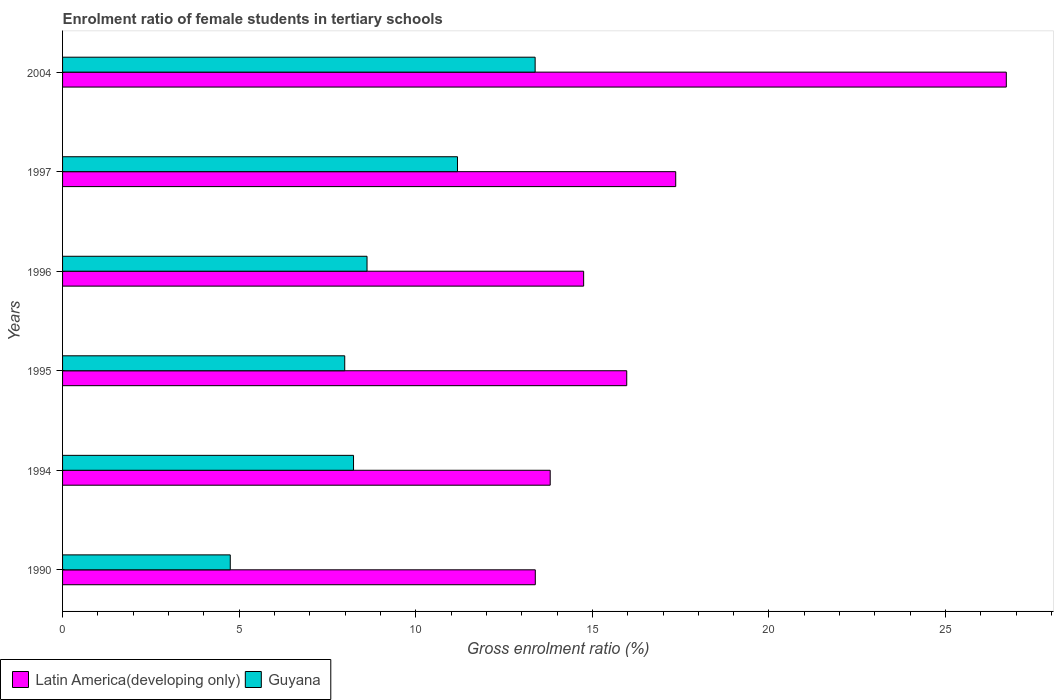How many different coloured bars are there?
Provide a short and direct response. 2. How many bars are there on the 3rd tick from the top?
Give a very brief answer. 2. What is the label of the 6th group of bars from the top?
Your answer should be compact. 1990. In how many cases, is the number of bars for a given year not equal to the number of legend labels?
Your answer should be compact. 0. What is the enrolment ratio of female students in tertiary schools in Latin America(developing only) in 1995?
Ensure brevity in your answer.  15.97. Across all years, what is the maximum enrolment ratio of female students in tertiary schools in Guyana?
Provide a succinct answer. 13.38. Across all years, what is the minimum enrolment ratio of female students in tertiary schools in Latin America(developing only)?
Your response must be concise. 13.38. In which year was the enrolment ratio of female students in tertiary schools in Guyana minimum?
Ensure brevity in your answer.  1990. What is the total enrolment ratio of female students in tertiary schools in Latin America(developing only) in the graph?
Offer a terse response. 101.99. What is the difference between the enrolment ratio of female students in tertiary schools in Latin America(developing only) in 1990 and that in 1994?
Offer a terse response. -0.42. What is the difference between the enrolment ratio of female students in tertiary schools in Latin America(developing only) in 1994 and the enrolment ratio of female students in tertiary schools in Guyana in 1995?
Offer a very short reply. 5.82. What is the average enrolment ratio of female students in tertiary schools in Latin America(developing only) per year?
Keep it short and to the point. 17. In the year 1996, what is the difference between the enrolment ratio of female students in tertiary schools in Guyana and enrolment ratio of female students in tertiary schools in Latin America(developing only)?
Your answer should be very brief. -6.13. In how many years, is the enrolment ratio of female students in tertiary schools in Latin America(developing only) greater than 7 %?
Your response must be concise. 6. What is the ratio of the enrolment ratio of female students in tertiary schools in Latin America(developing only) in 1990 to that in 2004?
Keep it short and to the point. 0.5. What is the difference between the highest and the second highest enrolment ratio of female students in tertiary schools in Latin America(developing only)?
Offer a very short reply. 9.36. What is the difference between the highest and the lowest enrolment ratio of female students in tertiary schools in Guyana?
Offer a terse response. 8.63. In how many years, is the enrolment ratio of female students in tertiary schools in Latin America(developing only) greater than the average enrolment ratio of female students in tertiary schools in Latin America(developing only) taken over all years?
Ensure brevity in your answer.  2. What does the 2nd bar from the top in 2004 represents?
Give a very brief answer. Latin America(developing only). What does the 2nd bar from the bottom in 1990 represents?
Ensure brevity in your answer.  Guyana. How many bars are there?
Offer a very short reply. 12. Are all the bars in the graph horizontal?
Keep it short and to the point. Yes. How many years are there in the graph?
Offer a terse response. 6. What is the difference between two consecutive major ticks on the X-axis?
Make the answer very short. 5. Does the graph contain any zero values?
Your response must be concise. No. How are the legend labels stacked?
Offer a very short reply. Horizontal. What is the title of the graph?
Provide a succinct answer. Enrolment ratio of female students in tertiary schools. What is the Gross enrolment ratio (%) in Latin America(developing only) in 1990?
Your answer should be compact. 13.38. What is the Gross enrolment ratio (%) in Guyana in 1990?
Make the answer very short. 4.75. What is the Gross enrolment ratio (%) in Latin America(developing only) in 1994?
Offer a very short reply. 13.81. What is the Gross enrolment ratio (%) of Guyana in 1994?
Offer a very short reply. 8.24. What is the Gross enrolment ratio (%) of Latin America(developing only) in 1995?
Offer a terse response. 15.97. What is the Gross enrolment ratio (%) of Guyana in 1995?
Provide a short and direct response. 7.99. What is the Gross enrolment ratio (%) of Latin America(developing only) in 1996?
Your answer should be very brief. 14.75. What is the Gross enrolment ratio (%) in Guyana in 1996?
Provide a succinct answer. 8.62. What is the Gross enrolment ratio (%) in Latin America(developing only) in 1997?
Offer a very short reply. 17.36. What is the Gross enrolment ratio (%) in Guyana in 1997?
Provide a short and direct response. 11.18. What is the Gross enrolment ratio (%) of Latin America(developing only) in 2004?
Your response must be concise. 26.72. What is the Gross enrolment ratio (%) in Guyana in 2004?
Your response must be concise. 13.38. Across all years, what is the maximum Gross enrolment ratio (%) of Latin America(developing only)?
Ensure brevity in your answer.  26.72. Across all years, what is the maximum Gross enrolment ratio (%) in Guyana?
Your answer should be compact. 13.38. Across all years, what is the minimum Gross enrolment ratio (%) in Latin America(developing only)?
Make the answer very short. 13.38. Across all years, what is the minimum Gross enrolment ratio (%) of Guyana?
Keep it short and to the point. 4.75. What is the total Gross enrolment ratio (%) of Latin America(developing only) in the graph?
Provide a short and direct response. 101.99. What is the total Gross enrolment ratio (%) of Guyana in the graph?
Your answer should be very brief. 54.15. What is the difference between the Gross enrolment ratio (%) of Latin America(developing only) in 1990 and that in 1994?
Provide a short and direct response. -0.42. What is the difference between the Gross enrolment ratio (%) of Guyana in 1990 and that in 1994?
Your response must be concise. -3.49. What is the difference between the Gross enrolment ratio (%) of Latin America(developing only) in 1990 and that in 1995?
Provide a succinct answer. -2.59. What is the difference between the Gross enrolment ratio (%) of Guyana in 1990 and that in 1995?
Offer a very short reply. -3.24. What is the difference between the Gross enrolment ratio (%) in Latin America(developing only) in 1990 and that in 1996?
Make the answer very short. -1.37. What is the difference between the Gross enrolment ratio (%) of Guyana in 1990 and that in 1996?
Offer a very short reply. -3.87. What is the difference between the Gross enrolment ratio (%) of Latin America(developing only) in 1990 and that in 1997?
Your response must be concise. -3.98. What is the difference between the Gross enrolment ratio (%) in Guyana in 1990 and that in 1997?
Provide a succinct answer. -6.43. What is the difference between the Gross enrolment ratio (%) of Latin America(developing only) in 1990 and that in 2004?
Provide a succinct answer. -13.34. What is the difference between the Gross enrolment ratio (%) of Guyana in 1990 and that in 2004?
Ensure brevity in your answer.  -8.63. What is the difference between the Gross enrolment ratio (%) of Latin America(developing only) in 1994 and that in 1995?
Offer a very short reply. -2.17. What is the difference between the Gross enrolment ratio (%) in Guyana in 1994 and that in 1995?
Provide a short and direct response. 0.25. What is the difference between the Gross enrolment ratio (%) in Latin America(developing only) in 1994 and that in 1996?
Provide a succinct answer. -0.95. What is the difference between the Gross enrolment ratio (%) of Guyana in 1994 and that in 1996?
Offer a very short reply. -0.38. What is the difference between the Gross enrolment ratio (%) in Latin America(developing only) in 1994 and that in 1997?
Your response must be concise. -3.55. What is the difference between the Gross enrolment ratio (%) in Guyana in 1994 and that in 1997?
Provide a succinct answer. -2.94. What is the difference between the Gross enrolment ratio (%) in Latin America(developing only) in 1994 and that in 2004?
Your response must be concise. -12.91. What is the difference between the Gross enrolment ratio (%) in Guyana in 1994 and that in 2004?
Offer a very short reply. -5.14. What is the difference between the Gross enrolment ratio (%) of Latin America(developing only) in 1995 and that in 1996?
Provide a short and direct response. 1.22. What is the difference between the Gross enrolment ratio (%) in Guyana in 1995 and that in 1996?
Give a very brief answer. -0.63. What is the difference between the Gross enrolment ratio (%) of Latin America(developing only) in 1995 and that in 1997?
Give a very brief answer. -1.39. What is the difference between the Gross enrolment ratio (%) in Guyana in 1995 and that in 1997?
Give a very brief answer. -3.19. What is the difference between the Gross enrolment ratio (%) of Latin America(developing only) in 1995 and that in 2004?
Ensure brevity in your answer.  -10.75. What is the difference between the Gross enrolment ratio (%) of Guyana in 1995 and that in 2004?
Give a very brief answer. -5.39. What is the difference between the Gross enrolment ratio (%) in Latin America(developing only) in 1996 and that in 1997?
Your answer should be very brief. -2.61. What is the difference between the Gross enrolment ratio (%) of Guyana in 1996 and that in 1997?
Make the answer very short. -2.56. What is the difference between the Gross enrolment ratio (%) in Latin America(developing only) in 1996 and that in 2004?
Give a very brief answer. -11.97. What is the difference between the Gross enrolment ratio (%) of Guyana in 1996 and that in 2004?
Offer a terse response. -4.76. What is the difference between the Gross enrolment ratio (%) of Latin America(developing only) in 1997 and that in 2004?
Your answer should be compact. -9.36. What is the difference between the Gross enrolment ratio (%) in Guyana in 1997 and that in 2004?
Give a very brief answer. -2.2. What is the difference between the Gross enrolment ratio (%) in Latin America(developing only) in 1990 and the Gross enrolment ratio (%) in Guyana in 1994?
Make the answer very short. 5.15. What is the difference between the Gross enrolment ratio (%) in Latin America(developing only) in 1990 and the Gross enrolment ratio (%) in Guyana in 1995?
Offer a very short reply. 5.4. What is the difference between the Gross enrolment ratio (%) in Latin America(developing only) in 1990 and the Gross enrolment ratio (%) in Guyana in 1996?
Provide a succinct answer. 4.76. What is the difference between the Gross enrolment ratio (%) in Latin America(developing only) in 1990 and the Gross enrolment ratio (%) in Guyana in 1997?
Your answer should be very brief. 2.2. What is the difference between the Gross enrolment ratio (%) in Latin America(developing only) in 1990 and the Gross enrolment ratio (%) in Guyana in 2004?
Ensure brevity in your answer.  0. What is the difference between the Gross enrolment ratio (%) in Latin America(developing only) in 1994 and the Gross enrolment ratio (%) in Guyana in 1995?
Give a very brief answer. 5.82. What is the difference between the Gross enrolment ratio (%) of Latin America(developing only) in 1994 and the Gross enrolment ratio (%) of Guyana in 1996?
Give a very brief answer. 5.19. What is the difference between the Gross enrolment ratio (%) of Latin America(developing only) in 1994 and the Gross enrolment ratio (%) of Guyana in 1997?
Give a very brief answer. 2.62. What is the difference between the Gross enrolment ratio (%) of Latin America(developing only) in 1994 and the Gross enrolment ratio (%) of Guyana in 2004?
Your answer should be very brief. 0.43. What is the difference between the Gross enrolment ratio (%) of Latin America(developing only) in 1995 and the Gross enrolment ratio (%) of Guyana in 1996?
Keep it short and to the point. 7.35. What is the difference between the Gross enrolment ratio (%) in Latin America(developing only) in 1995 and the Gross enrolment ratio (%) in Guyana in 1997?
Your response must be concise. 4.79. What is the difference between the Gross enrolment ratio (%) in Latin America(developing only) in 1995 and the Gross enrolment ratio (%) in Guyana in 2004?
Offer a terse response. 2.59. What is the difference between the Gross enrolment ratio (%) of Latin America(developing only) in 1996 and the Gross enrolment ratio (%) of Guyana in 1997?
Offer a terse response. 3.57. What is the difference between the Gross enrolment ratio (%) of Latin America(developing only) in 1996 and the Gross enrolment ratio (%) of Guyana in 2004?
Your answer should be very brief. 1.37. What is the difference between the Gross enrolment ratio (%) of Latin America(developing only) in 1997 and the Gross enrolment ratio (%) of Guyana in 2004?
Offer a very short reply. 3.98. What is the average Gross enrolment ratio (%) in Latin America(developing only) per year?
Keep it short and to the point. 17. What is the average Gross enrolment ratio (%) of Guyana per year?
Provide a short and direct response. 9.03. In the year 1990, what is the difference between the Gross enrolment ratio (%) in Latin America(developing only) and Gross enrolment ratio (%) in Guyana?
Ensure brevity in your answer.  8.64. In the year 1994, what is the difference between the Gross enrolment ratio (%) in Latin America(developing only) and Gross enrolment ratio (%) in Guyana?
Make the answer very short. 5.57. In the year 1995, what is the difference between the Gross enrolment ratio (%) of Latin America(developing only) and Gross enrolment ratio (%) of Guyana?
Your response must be concise. 7.98. In the year 1996, what is the difference between the Gross enrolment ratio (%) of Latin America(developing only) and Gross enrolment ratio (%) of Guyana?
Your answer should be very brief. 6.13. In the year 1997, what is the difference between the Gross enrolment ratio (%) of Latin America(developing only) and Gross enrolment ratio (%) of Guyana?
Provide a succinct answer. 6.18. In the year 2004, what is the difference between the Gross enrolment ratio (%) of Latin America(developing only) and Gross enrolment ratio (%) of Guyana?
Give a very brief answer. 13.34. What is the ratio of the Gross enrolment ratio (%) of Latin America(developing only) in 1990 to that in 1994?
Your answer should be very brief. 0.97. What is the ratio of the Gross enrolment ratio (%) of Guyana in 1990 to that in 1994?
Your answer should be compact. 0.58. What is the ratio of the Gross enrolment ratio (%) in Latin America(developing only) in 1990 to that in 1995?
Offer a very short reply. 0.84. What is the ratio of the Gross enrolment ratio (%) of Guyana in 1990 to that in 1995?
Make the answer very short. 0.59. What is the ratio of the Gross enrolment ratio (%) in Latin America(developing only) in 1990 to that in 1996?
Make the answer very short. 0.91. What is the ratio of the Gross enrolment ratio (%) of Guyana in 1990 to that in 1996?
Offer a very short reply. 0.55. What is the ratio of the Gross enrolment ratio (%) of Latin America(developing only) in 1990 to that in 1997?
Ensure brevity in your answer.  0.77. What is the ratio of the Gross enrolment ratio (%) of Guyana in 1990 to that in 1997?
Your answer should be compact. 0.42. What is the ratio of the Gross enrolment ratio (%) of Latin America(developing only) in 1990 to that in 2004?
Make the answer very short. 0.5. What is the ratio of the Gross enrolment ratio (%) in Guyana in 1990 to that in 2004?
Offer a very short reply. 0.35. What is the ratio of the Gross enrolment ratio (%) of Latin America(developing only) in 1994 to that in 1995?
Give a very brief answer. 0.86. What is the ratio of the Gross enrolment ratio (%) in Guyana in 1994 to that in 1995?
Give a very brief answer. 1.03. What is the ratio of the Gross enrolment ratio (%) of Latin America(developing only) in 1994 to that in 1996?
Make the answer very short. 0.94. What is the ratio of the Gross enrolment ratio (%) in Guyana in 1994 to that in 1996?
Your answer should be very brief. 0.96. What is the ratio of the Gross enrolment ratio (%) of Latin America(developing only) in 1994 to that in 1997?
Give a very brief answer. 0.8. What is the ratio of the Gross enrolment ratio (%) in Guyana in 1994 to that in 1997?
Ensure brevity in your answer.  0.74. What is the ratio of the Gross enrolment ratio (%) in Latin America(developing only) in 1994 to that in 2004?
Keep it short and to the point. 0.52. What is the ratio of the Gross enrolment ratio (%) in Guyana in 1994 to that in 2004?
Make the answer very short. 0.62. What is the ratio of the Gross enrolment ratio (%) in Latin America(developing only) in 1995 to that in 1996?
Make the answer very short. 1.08. What is the ratio of the Gross enrolment ratio (%) of Guyana in 1995 to that in 1996?
Provide a short and direct response. 0.93. What is the ratio of the Gross enrolment ratio (%) of Latin America(developing only) in 1995 to that in 1997?
Provide a short and direct response. 0.92. What is the ratio of the Gross enrolment ratio (%) of Guyana in 1995 to that in 1997?
Your answer should be very brief. 0.71. What is the ratio of the Gross enrolment ratio (%) in Latin America(developing only) in 1995 to that in 2004?
Offer a terse response. 0.6. What is the ratio of the Gross enrolment ratio (%) in Guyana in 1995 to that in 2004?
Your answer should be very brief. 0.6. What is the ratio of the Gross enrolment ratio (%) in Latin America(developing only) in 1996 to that in 1997?
Keep it short and to the point. 0.85. What is the ratio of the Gross enrolment ratio (%) in Guyana in 1996 to that in 1997?
Ensure brevity in your answer.  0.77. What is the ratio of the Gross enrolment ratio (%) in Latin America(developing only) in 1996 to that in 2004?
Make the answer very short. 0.55. What is the ratio of the Gross enrolment ratio (%) of Guyana in 1996 to that in 2004?
Your answer should be compact. 0.64. What is the ratio of the Gross enrolment ratio (%) of Latin America(developing only) in 1997 to that in 2004?
Provide a short and direct response. 0.65. What is the ratio of the Gross enrolment ratio (%) of Guyana in 1997 to that in 2004?
Make the answer very short. 0.84. What is the difference between the highest and the second highest Gross enrolment ratio (%) in Latin America(developing only)?
Give a very brief answer. 9.36. What is the difference between the highest and the second highest Gross enrolment ratio (%) in Guyana?
Provide a succinct answer. 2.2. What is the difference between the highest and the lowest Gross enrolment ratio (%) in Latin America(developing only)?
Offer a very short reply. 13.34. What is the difference between the highest and the lowest Gross enrolment ratio (%) of Guyana?
Offer a very short reply. 8.63. 